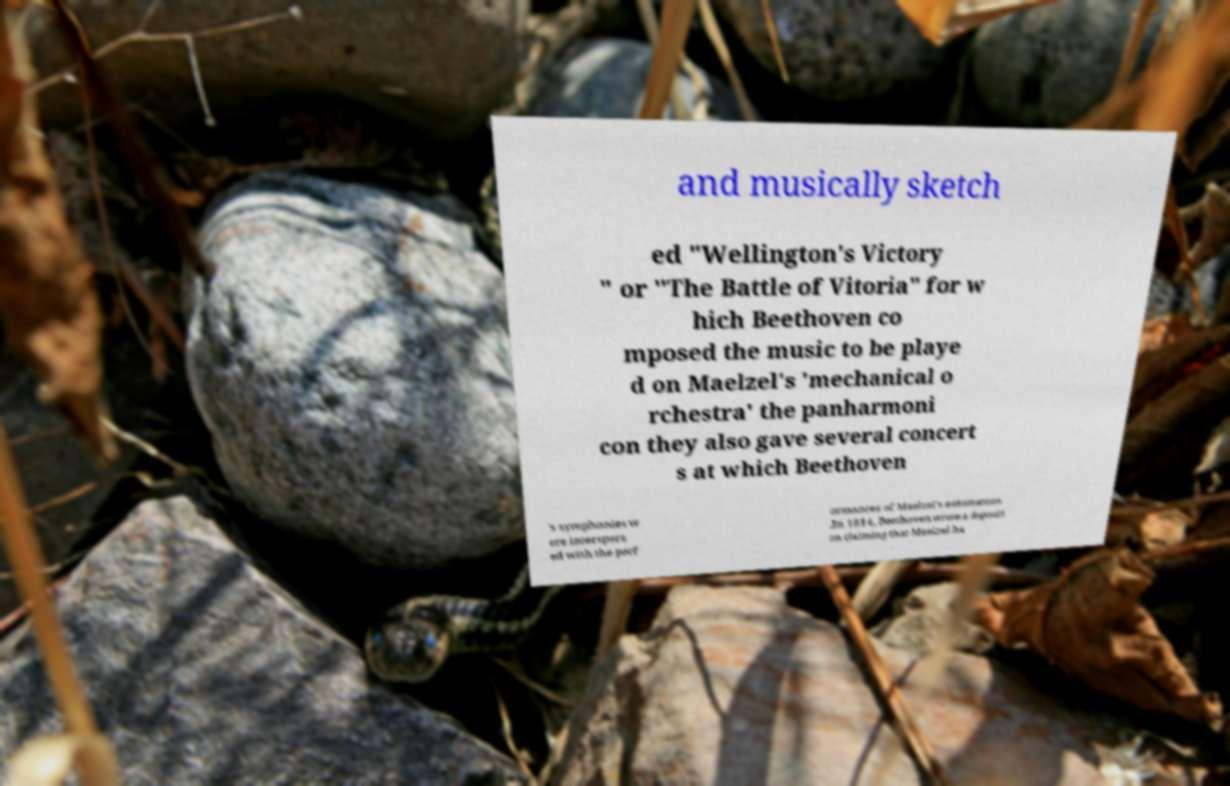Can you read and provide the text displayed in the image?This photo seems to have some interesting text. Can you extract and type it out for me? and musically sketch ed "Wellington's Victory " or "The Battle of Vitoria" for w hich Beethoven co mposed the music to be playe d on Maelzel's 'mechanical o rchestra' the panharmoni con they also gave several concert s at which Beethoven 's symphonies w ere interspers ed with the perf ormances of Maelzel's automatons .In 1814, Beethoven wrote a depositi on claiming that Maelzel ha 